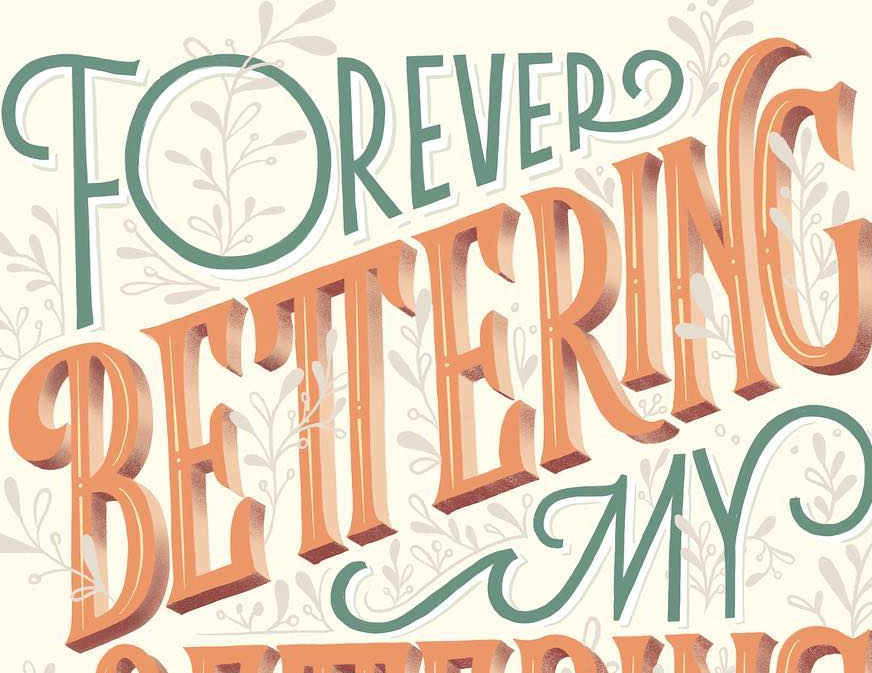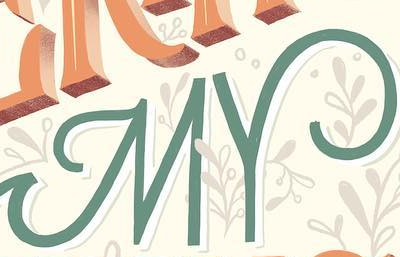Identify the words shown in these images in order, separated by a semicolon. BETTERING; MY 